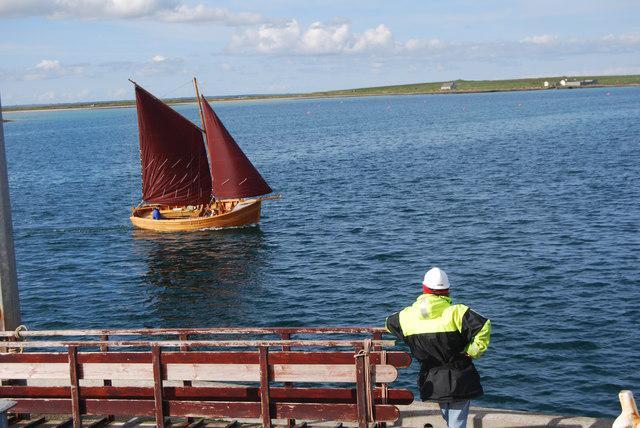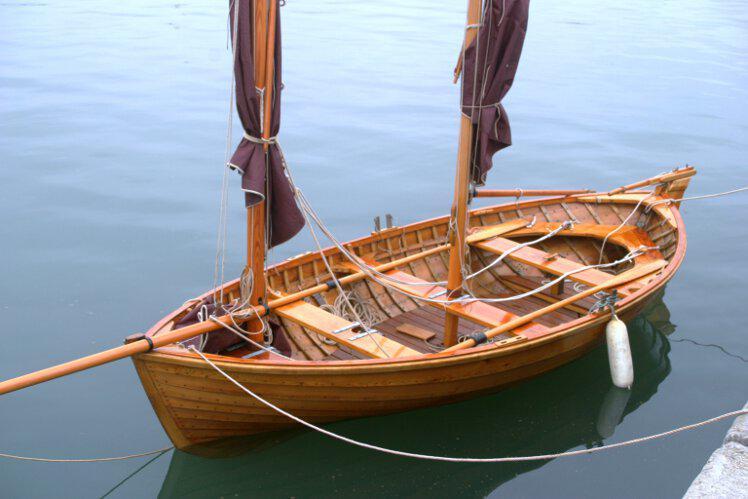The first image is the image on the left, the second image is the image on the right. For the images shown, is this caption "At least three people sit in boats with red sails." true? Answer yes or no. No. The first image is the image on the left, the second image is the image on the right. Examine the images to the left and right. Is the description "There is at least three humans riding in a sailboat." accurate? Answer yes or no. No. 